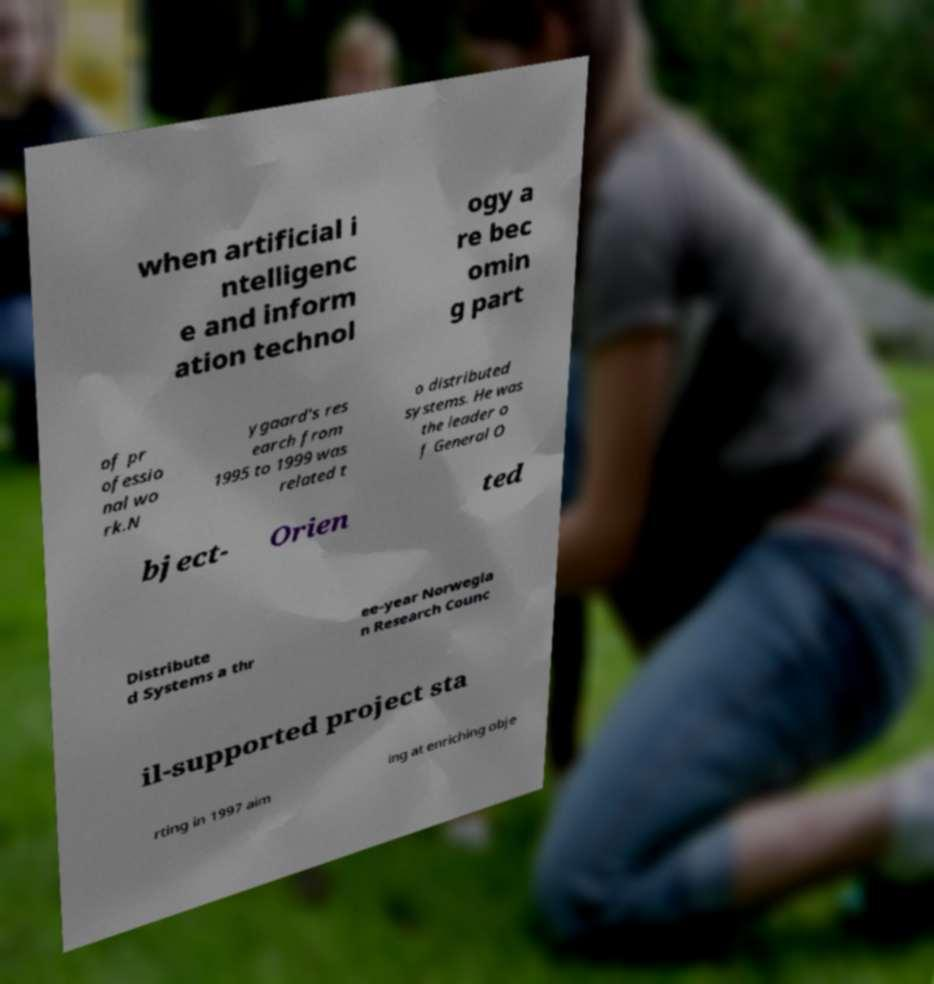I need the written content from this picture converted into text. Can you do that? when artificial i ntelligenc e and inform ation technol ogy a re bec omin g part of pr ofessio nal wo rk.N ygaard's res earch from 1995 to 1999 was related t o distributed systems. He was the leader o f General O bject- Orien ted Distribute d Systems a thr ee-year Norwegia n Research Counc il-supported project sta rting in 1997 aim ing at enriching obje 